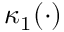Convert formula to latex. <formula><loc_0><loc_0><loc_500><loc_500>\kappa _ { 1 } ( \cdot )</formula> 